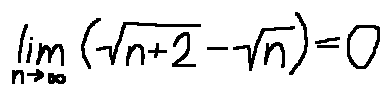<formula> <loc_0><loc_0><loc_500><loc_500>\lim \lim i t s _ { n \rightarrow \infty } ( \sqrt { n + 2 } - \sqrt { n } ) = 0</formula> 